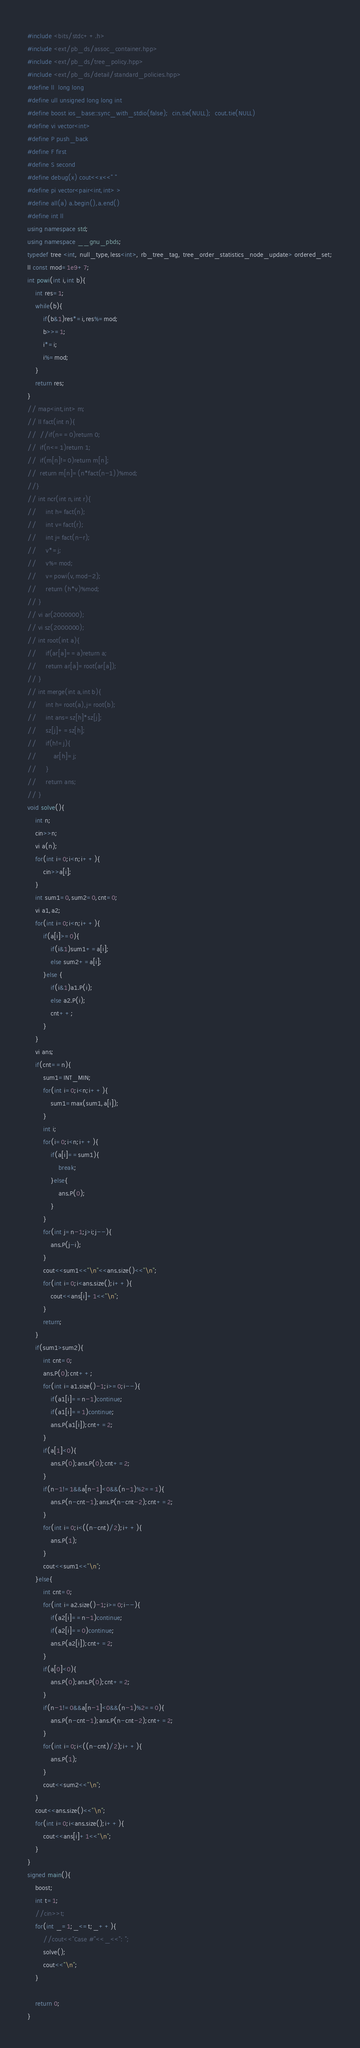Convert code to text. <code><loc_0><loc_0><loc_500><loc_500><_C++_>#include <bits/stdc++.h>
#include <ext/pb_ds/assoc_container.hpp>
#include <ext/pb_ds/tree_policy.hpp>
#include <ext/pb_ds/detail/standard_policies.hpp>
#define ll  long long 
#define ull unsigned long long int
#define boost ios_base::sync_with_stdio(false);	cin.tie(NULL);	cout.tie(NULL)
#define vi vector<int>
#define P push_back
#define F first
#define S second
#define debug(x) cout<<x<<" "
#define pi vector<pair<int,int> >
#define all(a) a.begin(),a.end()
#define int ll
using namespace std;
using namespace __gnu_pbds;
typedef tree <int, null_type,less<int>, rb_tree_tag, tree_order_statistics_node_update> ordered_set;
ll const mod=1e9+7;
int powi(int i,int b){
    int res=1;
    while(b){
        if(b&1)res*=i,res%=mod;
        b>>=1;
        i*=i;
        i%=mod;
    }
    return res;
}
// map<int,int> m;
// ll fact(int n){
// 	//if(n==0)return 0;
// 	if(n<=1)return 1;
// 	if(m[n]!=0)return m[n];
// 	return m[n]=(n*fact(n-1))%mod;
//}
// int ncr(int n,int r){
//     int h=fact(n);
//     int v=fact(r);
//     int j=fact(n-r);
//     v*=j;
//     v%=mod;
//     v=powi(v,mod-2);
//     return (h*v)%mod;
// }
// vi ar(2000000);
// vi sz(2000000);
// int root(int a){
//     if(ar[a]==a)return a;
//     return ar[a]=root(ar[a]);
// }
// int merge(int a,int b){
//     int h=root(a),j=root(b);
//     int ans=sz[h]*sz[j];
//     sz[j]+=sz[h];
//     if(h!=j){
//         ar[h]=j;
//     }
//     return ans;
// } 
void solve(){
    int n;
    cin>>n;
    vi a(n);
    for(int i=0;i<n;i++){
        cin>>a[i];
    }
    int sum1=0,sum2=0,cnt=0;
    vi a1,a2;
    for(int i=0;i<n;i++){
        if(a[i]>=0){
            if(i&1)sum1+=a[i];
            else sum2+=a[i];
        }else {
            if(i&1)a1.P(i);
            else a2.P(i);
            cnt++;
        }
    }
    vi ans;
    if(cnt==n){
        sum1=INT_MIN;
        for(int i=0;i<n;i++){
            sum1=max(sum1,a[i]);
        }
        int i;
        for(i=0;i<n;i++){
            if(a[i]==sum1){
                break;
            }else{
                ans.P(0);
            }
        }
        for(int j=n-1;j>i;j--){
            ans.P(j-i);
        }
        cout<<sum1<<"\n"<<ans.size()<<"\n";
        for(int i=0;i<ans.size();i++){
            cout<<ans[i]+1<<"\n";
        }
        return;
    }
    if(sum1>sum2){
        int cnt=0;
        ans.P(0);cnt++;
        for(int i=a1.size()-1;i>=0;i--){
            if(a1[i]==n-1)continue;
            if(a1[i]==1)continue;
            ans.P(a1[i]);cnt+=2;
        }
        if(a[1]<0){
            ans.P(0);ans.P(0);cnt+=2;
        }
        if(n-1!=1&&a[n-1]<0&&(n-1)%2==1){
            ans.P(n-cnt-1);ans.P(n-cnt-2);cnt+=2;
        }
        for(int i=0;i<((n-cnt)/2);i++){
            ans.P(1);
        }
        cout<<sum1<<"\n";
    }else{
        int cnt=0;
        for(int i=a2.size()-1;i>=0;i--){
            if(a2[i]==n-1)continue;
            if(a2[i]==0)continue;
            ans.P(a2[i]);cnt+=2;
        }
        if(a[0]<0){
            ans.P(0);ans.P(0);cnt+=2;
        }
        if(n-1!=0&&a[n-1]<0&&(n-1)%2==0){
            ans.P(n-cnt-1);ans.P(n-cnt-2);cnt+=2;
        }
        for(int i=0;i<((n-cnt)/2);i++){
            ans.P(1);
        }
        cout<<sum2<<"\n";
    }
    cout<<ans.size()<<"\n";
    for(int i=0;i<ans.size();i++){
        cout<<ans[i]+1<<"\n";
    }
}
signed main(){
    boost;
    int t=1;
    //cin>>t;
    for(int _=1;_<=t;_++){
        //cout<<"Case #"<<_<<": ";
        solve();
        cout<<"\n";
    }
    
    return 0;
}</code> 